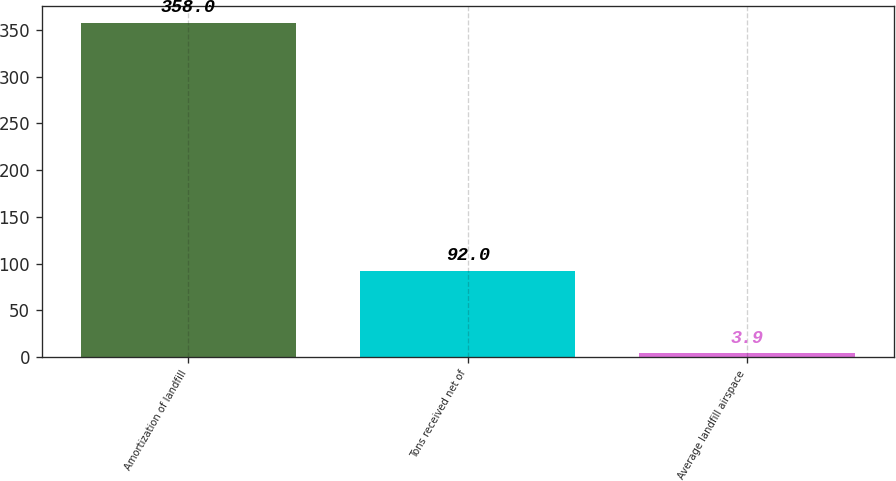Convert chart to OTSL. <chart><loc_0><loc_0><loc_500><loc_500><bar_chart><fcel>Amortization of landfill<fcel>Tons received net of<fcel>Average landfill airspace<nl><fcel>358<fcel>92<fcel>3.9<nl></chart> 